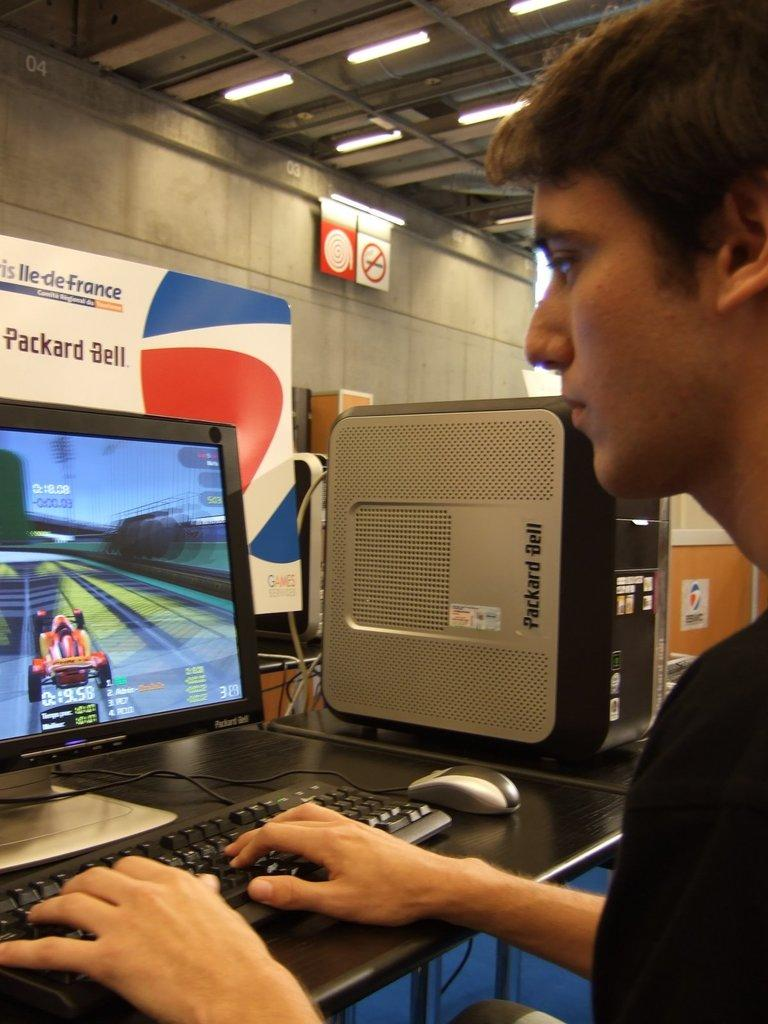<image>
Present a compact description of the photo's key features. A young male is playing a game on a Packard Bell computer. 